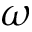<formula> <loc_0><loc_0><loc_500><loc_500>\omega</formula> 